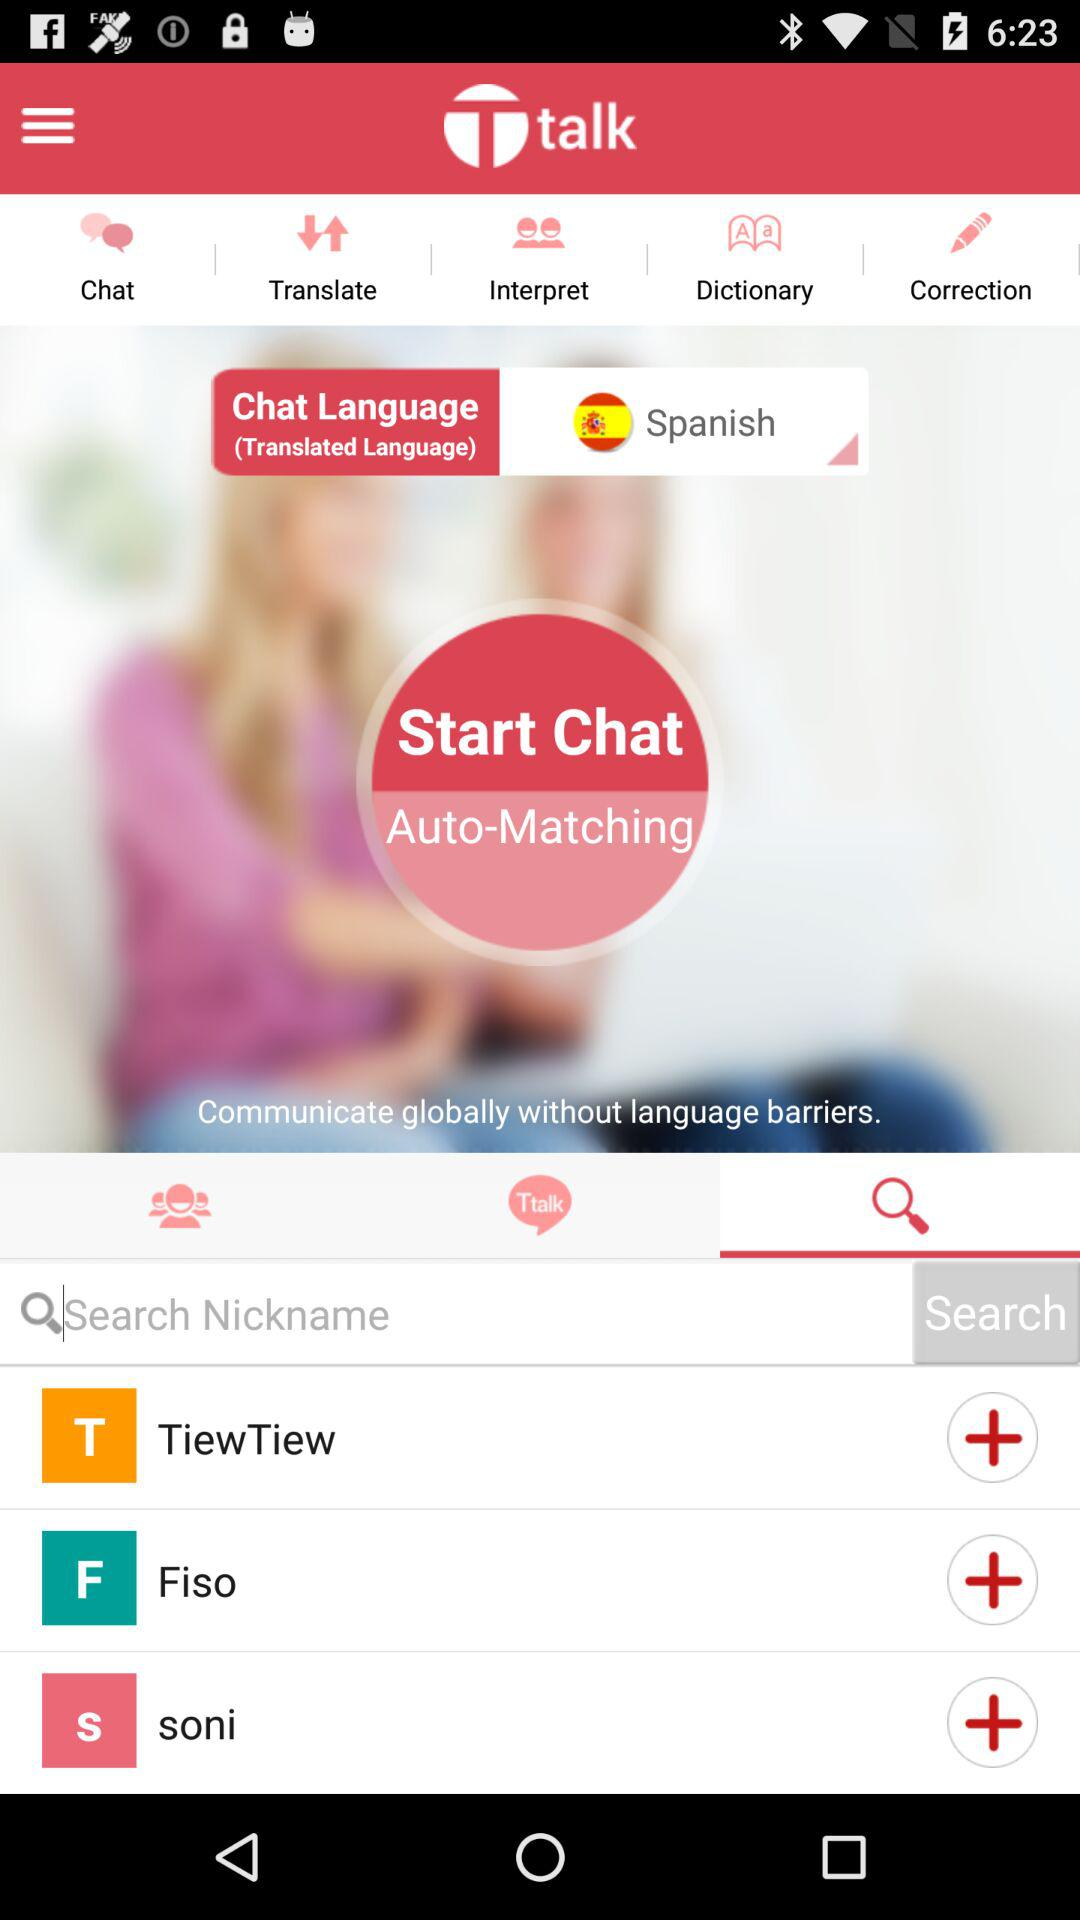What is the application name? The application name is "Ttalk". 